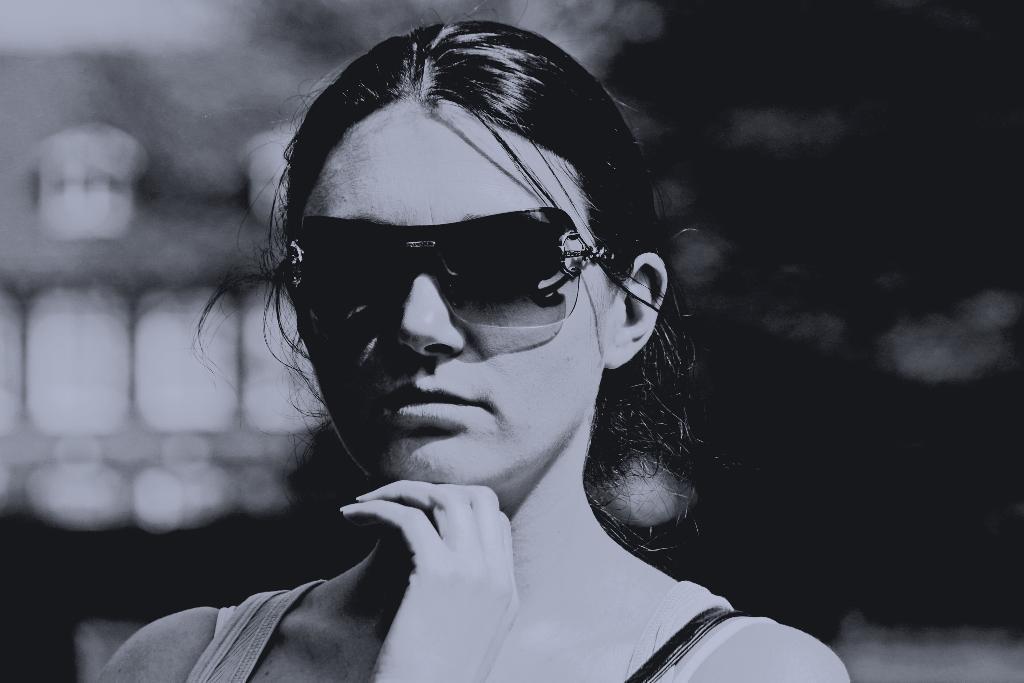Describe this image in one or two sentences. This is a black and white image. Here I can see a woman wearing goggles and looking at the picture. The background is blurred. 